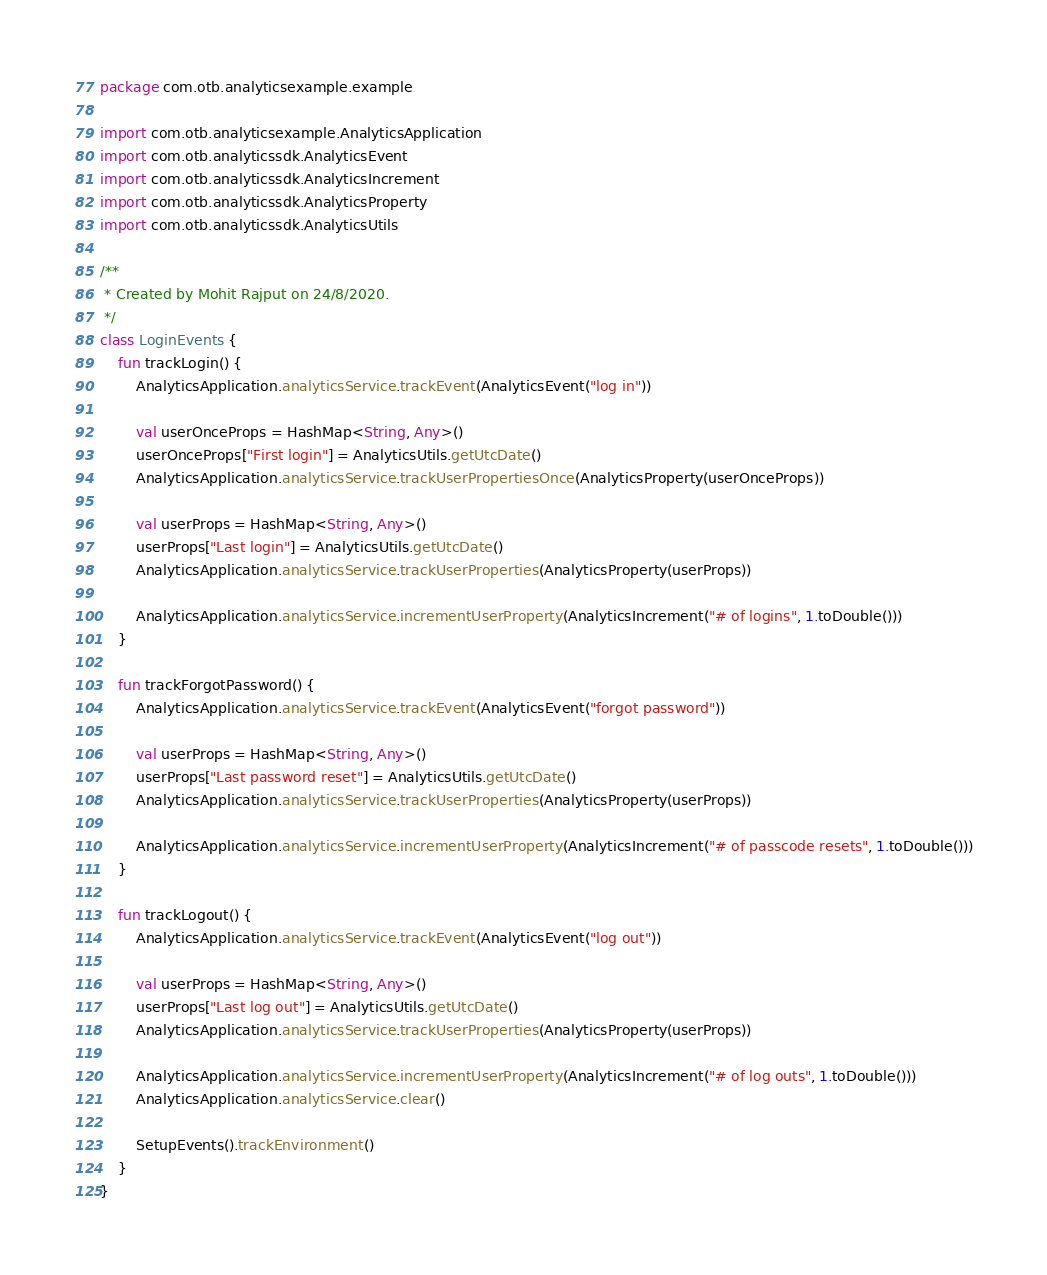<code> <loc_0><loc_0><loc_500><loc_500><_Kotlin_>package com.otb.analyticsexample.example

import com.otb.analyticsexample.AnalyticsApplication
import com.otb.analyticssdk.AnalyticsEvent
import com.otb.analyticssdk.AnalyticsIncrement
import com.otb.analyticssdk.AnalyticsProperty
import com.otb.analyticssdk.AnalyticsUtils

/**
 * Created by Mohit Rajput on 24/8/2020.
 */
class LoginEvents {
    fun trackLogin() {
        AnalyticsApplication.analyticsService.trackEvent(AnalyticsEvent("log in"))

        val userOnceProps = HashMap<String, Any>()
        userOnceProps["First login"] = AnalyticsUtils.getUtcDate()
        AnalyticsApplication.analyticsService.trackUserPropertiesOnce(AnalyticsProperty(userOnceProps))

        val userProps = HashMap<String, Any>()
        userProps["Last login"] = AnalyticsUtils.getUtcDate()
        AnalyticsApplication.analyticsService.trackUserProperties(AnalyticsProperty(userProps))

        AnalyticsApplication.analyticsService.incrementUserProperty(AnalyticsIncrement("# of logins", 1.toDouble()))
    }

    fun trackForgotPassword() {
        AnalyticsApplication.analyticsService.trackEvent(AnalyticsEvent("forgot password"))

        val userProps = HashMap<String, Any>()
        userProps["Last password reset"] = AnalyticsUtils.getUtcDate()
        AnalyticsApplication.analyticsService.trackUserProperties(AnalyticsProperty(userProps))

        AnalyticsApplication.analyticsService.incrementUserProperty(AnalyticsIncrement("# of passcode resets", 1.toDouble()))
    }

    fun trackLogout() {
        AnalyticsApplication.analyticsService.trackEvent(AnalyticsEvent("log out"))

        val userProps = HashMap<String, Any>()
        userProps["Last log out"] = AnalyticsUtils.getUtcDate()
        AnalyticsApplication.analyticsService.trackUserProperties(AnalyticsProperty(userProps))

        AnalyticsApplication.analyticsService.incrementUserProperty(AnalyticsIncrement("# of log outs", 1.toDouble()))
        AnalyticsApplication.analyticsService.clear()

        SetupEvents().trackEnvironment()
    }
}</code> 